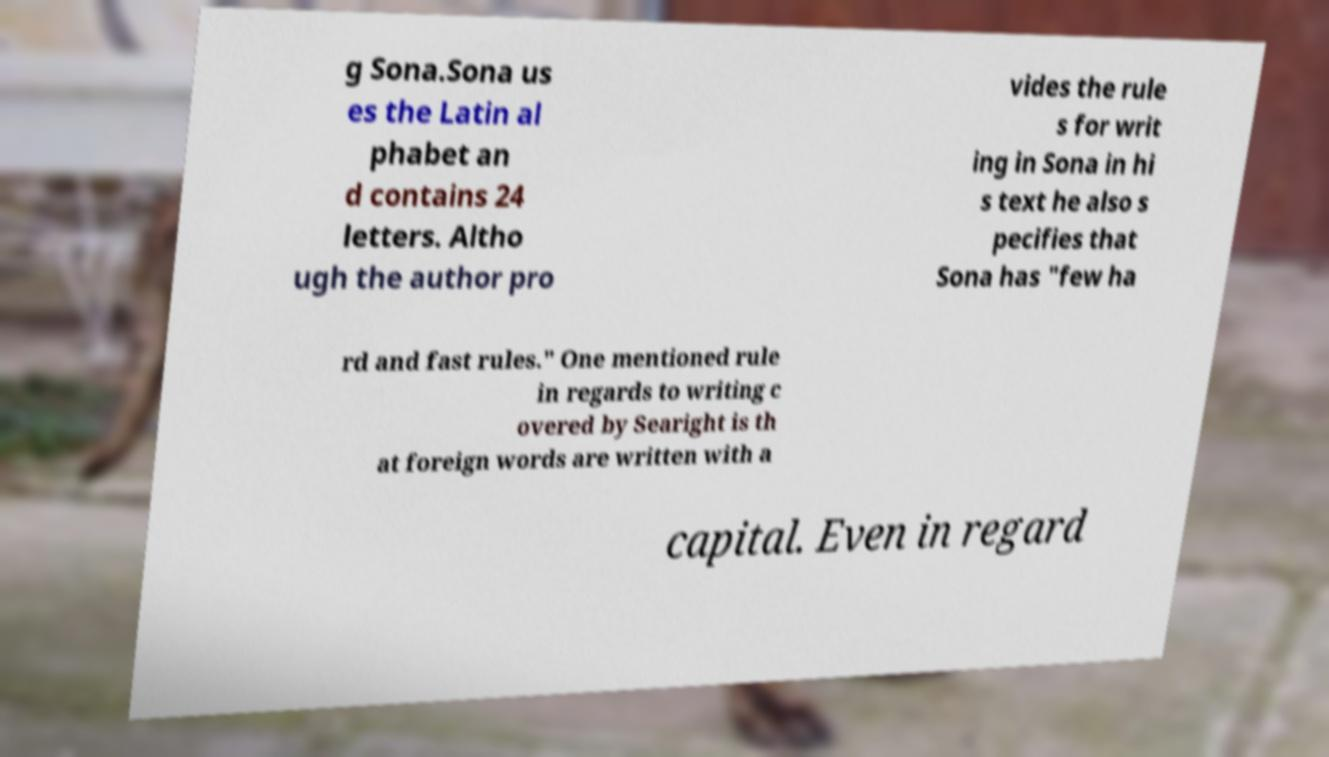Please read and relay the text visible in this image. What does it say? g Sona.Sona us es the Latin al phabet an d contains 24 letters. Altho ugh the author pro vides the rule s for writ ing in Sona in hi s text he also s pecifies that Sona has "few ha rd and fast rules." One mentioned rule in regards to writing c overed by Searight is th at foreign words are written with a capital. Even in regard 